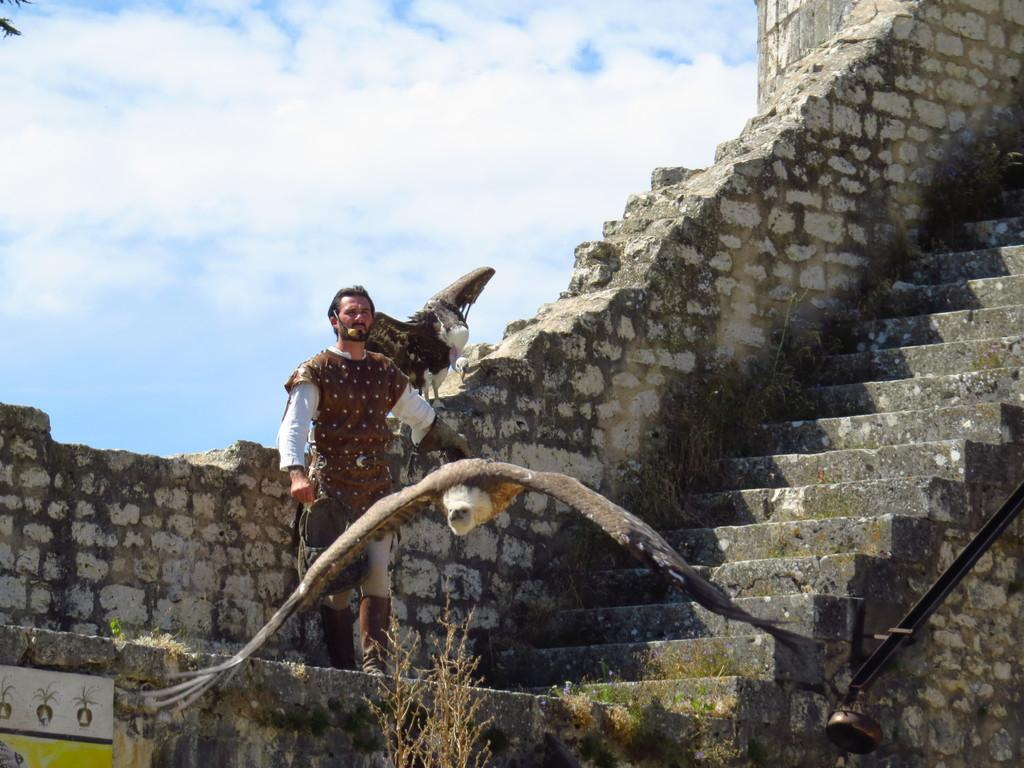What is the person in the image doing? There is a person standing on a building in the image. What can be seen in the background of the image? There are star-shaped objects, which appear to be star-shaped decorations or star-shaped windows, visible in the image. What other living creatures are present in the image? There are birds present in the image. What type of window treatment can be seen on the bit of wind in the image? There is no window or wind present in the image, so it is not possible to determine what type of window treatment might be on them. 